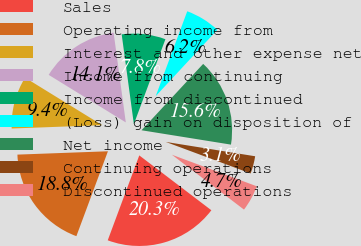Convert chart. <chart><loc_0><loc_0><loc_500><loc_500><pie_chart><fcel>Sales<fcel>Operating income from<fcel>Interest and other expense net<fcel>Income from continuing<fcel>Income from discontinued<fcel>(Loss) gain on disposition of<fcel>Net income<fcel>Continuing operations<fcel>Discontinued operations<nl><fcel>20.31%<fcel>18.75%<fcel>9.38%<fcel>14.06%<fcel>7.81%<fcel>6.25%<fcel>15.62%<fcel>3.13%<fcel>4.69%<nl></chart> 